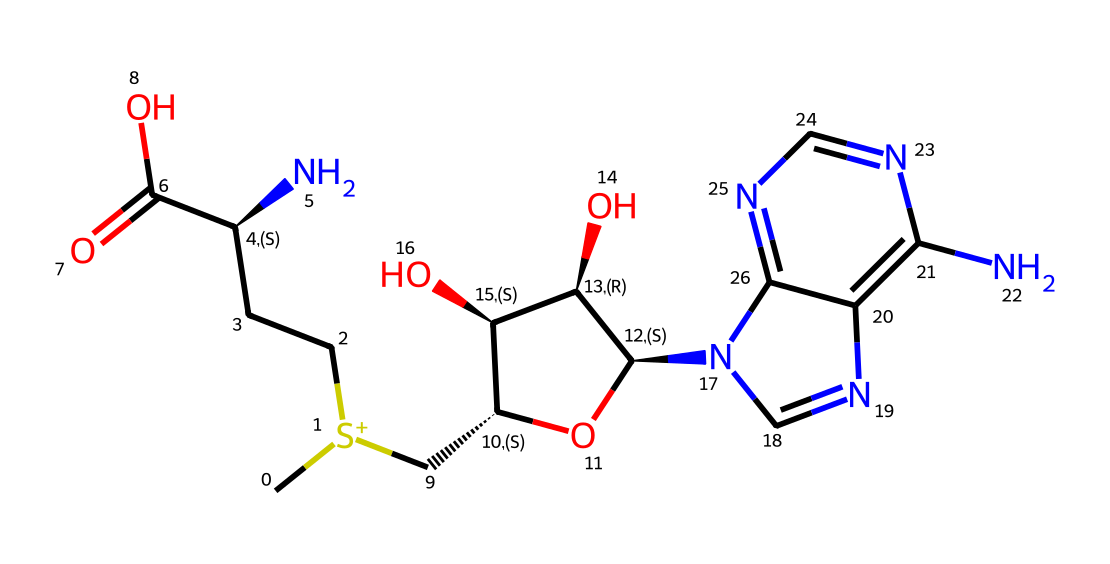What is the molecular formula of S-Adenosyl methionine? To determine the molecular formula, we analyze the structure for each atom present: counting carbons, hydrogens, nitrogens, oxygen, and sulfur. The SMILES string gives us 14 carbons, 19 hydrogens, 5 nitrogens, 5 oxygens, and 1 sulfur. Therefore, the molecular formula is C14H19N5O5S.
Answer: C14H19N5O5S How many nitrogen atoms are in the chemical structure? By examining the SMILES representation, we can identify nitrogen atoms denoted by 'N.' Upon counting, there are 5 nitrogen atoms present in the structure.
Answer: 5 What type of chemical reaction is S-Adenosyl methionine primarily involved in? S-Adenosyl methionine acts primarily as a methyl donor in methylation reactions, which are crucial for modifying DNA, affecting gene expression and epigenetics.
Answer: methylation Which class of compounds does S-Adenosyl methionine belong to? S-Adenosyl methionine is categorized as an organosulfur compound due to the presence of sulfur in its structure, indicating it belongs to this specific class.
Answer: organosulfur How many total atoms are in the S-Adenosyl methionine molecule? To find the total number of atoms, we sum the counts of each type: 14 carbons, 19 hydrogens, 5 nitrogens, 5 oxygens, and 1 sulfur. Adding these gives a total atom count of 44.
Answer: 44 Which functional group in S-Adenosyl methionine is responsible for its biological activity? The sulfonium group present in S-Adenosyl methionine is vital for its role as a methyl donor, thus facilitating its biological activity, especially in methylation processes.
Answer: sulfonium What is the stereochemistry indicated in the compound? The stereochemistry is indicated by '@' symbols in the SMILES string, signifying chiral centers. There are two chiral centers noted in this structure.
Answer: 2 